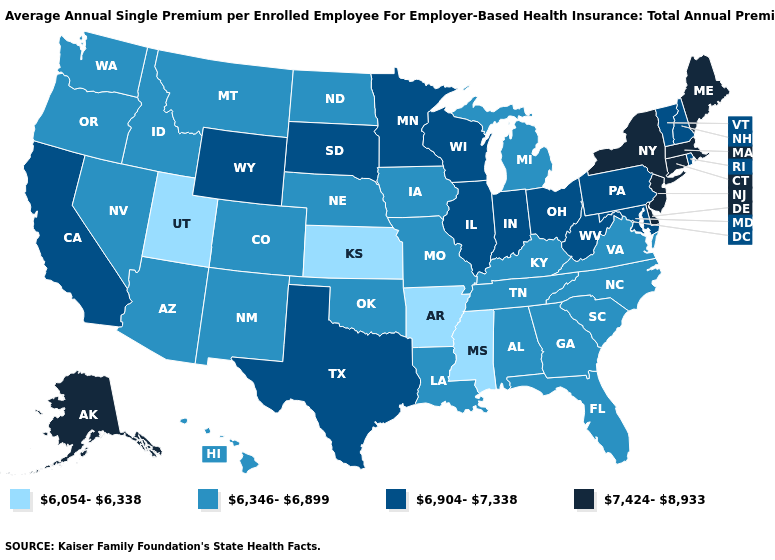Name the states that have a value in the range 6,904-7,338?
Be succinct. California, Illinois, Indiana, Maryland, Minnesota, New Hampshire, Ohio, Pennsylvania, Rhode Island, South Dakota, Texas, Vermont, West Virginia, Wisconsin, Wyoming. Name the states that have a value in the range 6,346-6,899?
Quick response, please. Alabama, Arizona, Colorado, Florida, Georgia, Hawaii, Idaho, Iowa, Kentucky, Louisiana, Michigan, Missouri, Montana, Nebraska, Nevada, New Mexico, North Carolina, North Dakota, Oklahoma, Oregon, South Carolina, Tennessee, Virginia, Washington. Among the states that border Oregon , does Idaho have the lowest value?
Answer briefly. Yes. Name the states that have a value in the range 6,054-6,338?
Keep it brief. Arkansas, Kansas, Mississippi, Utah. Name the states that have a value in the range 6,904-7,338?
Keep it brief. California, Illinois, Indiana, Maryland, Minnesota, New Hampshire, Ohio, Pennsylvania, Rhode Island, South Dakota, Texas, Vermont, West Virginia, Wisconsin, Wyoming. Among the states that border Alabama , which have the lowest value?
Be succinct. Mississippi. Does Iowa have the same value as Oklahoma?
Be succinct. Yes. What is the value of New York?
Keep it brief. 7,424-8,933. Name the states that have a value in the range 6,346-6,899?
Be succinct. Alabama, Arizona, Colorado, Florida, Georgia, Hawaii, Idaho, Iowa, Kentucky, Louisiana, Michigan, Missouri, Montana, Nebraska, Nevada, New Mexico, North Carolina, North Dakota, Oklahoma, Oregon, South Carolina, Tennessee, Virginia, Washington. What is the value of Texas?
Answer briefly. 6,904-7,338. What is the value of Connecticut?
Quick response, please. 7,424-8,933. Does New Hampshire have a lower value than Connecticut?
Short answer required. Yes. Name the states that have a value in the range 7,424-8,933?
Be succinct. Alaska, Connecticut, Delaware, Maine, Massachusetts, New Jersey, New York. What is the lowest value in states that border Louisiana?
Answer briefly. 6,054-6,338. 